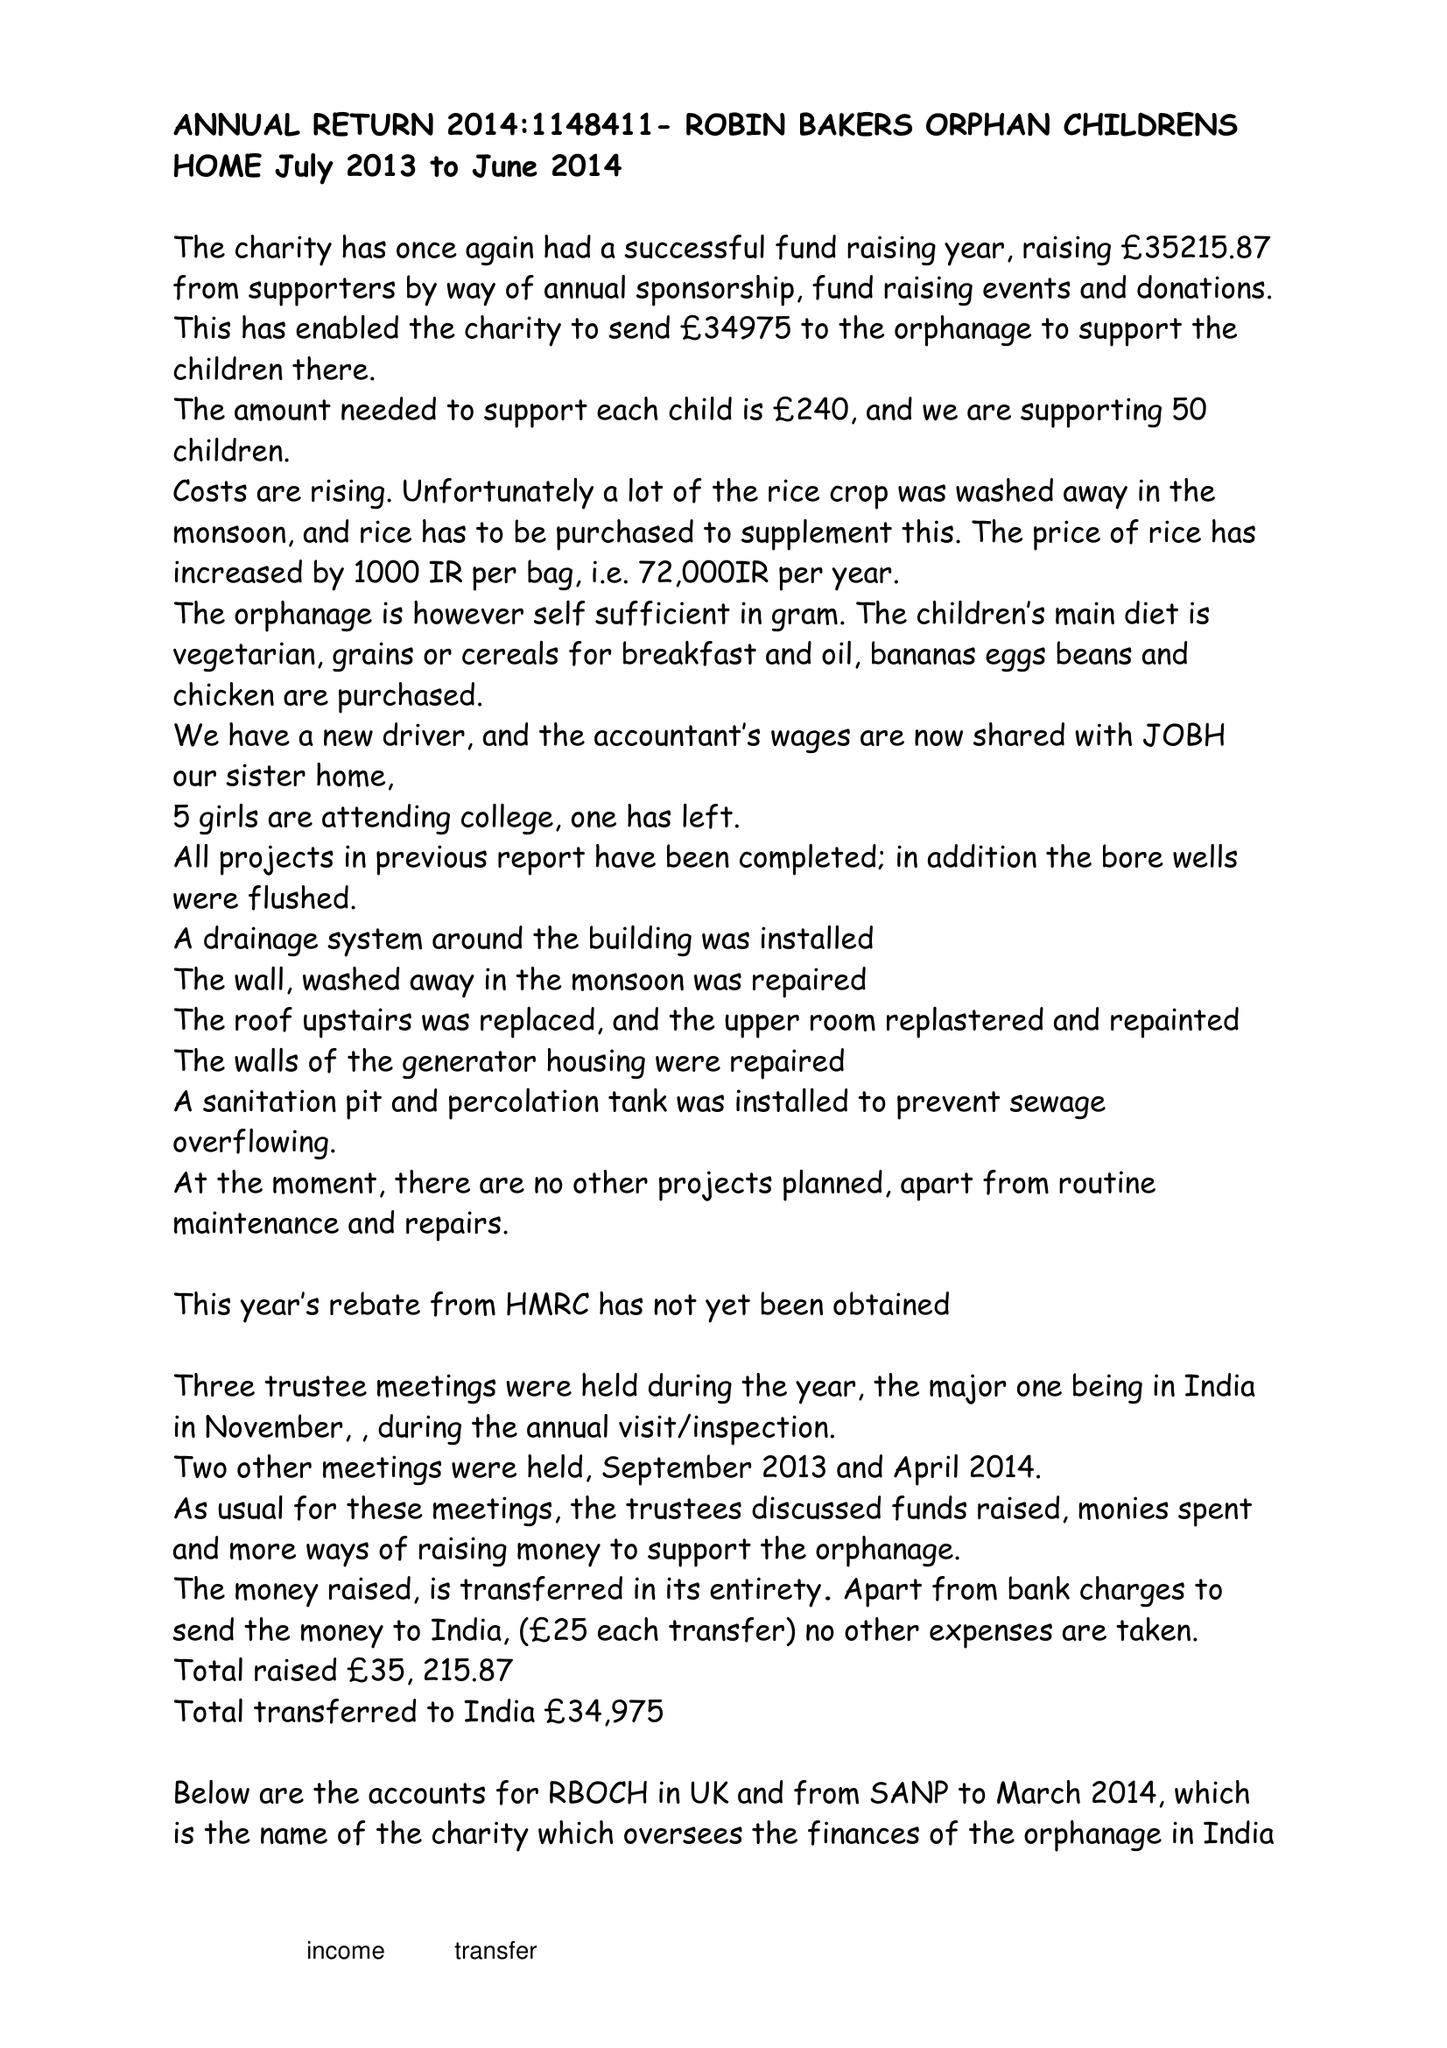What is the value for the address__post_town?
Answer the question using a single word or phrase. BRISTOL 